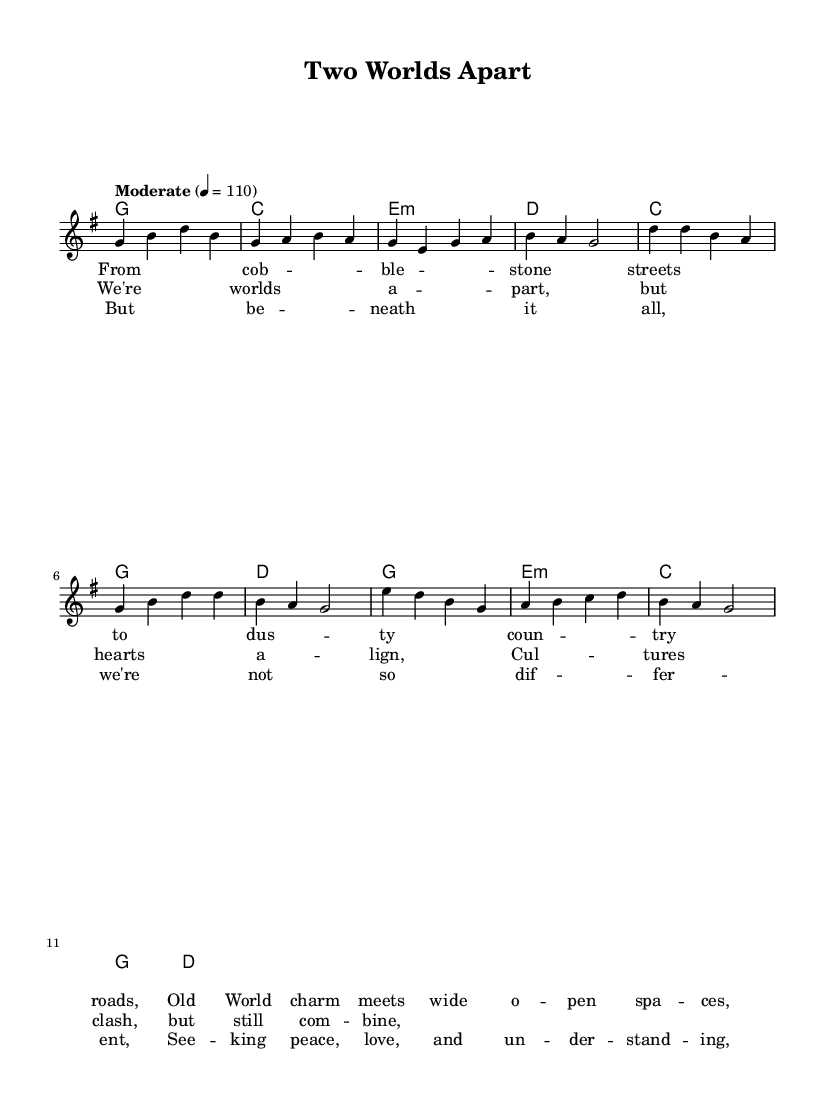What is the key signature of this music? The key signature is G major, which has one sharp (F#).
Answer: G major What is the time signature of this music? The time signature is 4/4, indicating four beats in each measure.
Answer: 4/4 What is the tempo marking of this music? The tempo is set to "Moderate" at 110 beats per minute.
Answer: Moderate How many measures are there in the chorus section? The chorus consists of four measures, as indicated by the chord progression and melody.
Answer: Four What is the primary theme of the lyrics? The lyrics focus on cultural differences and similarities between Europe and rural America, emphasizing heart alignment despite differences.
Answer: Cultural differences and similarities What is the chord that accompanies the bridge? The chord progression for the bridge includes E minor, C major, G major, and D major.
Answer: E minor How do the verses of the song differ melodically from the chorus? The verses have a more reflective and narrative melody compared to the more uplifting and resonant melody of the chorus, creating a contrast in emotional delivery.
Answer: Reflective vs. uplifting 